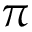Convert formula to latex. <formula><loc_0><loc_0><loc_500><loc_500>\pi</formula> 